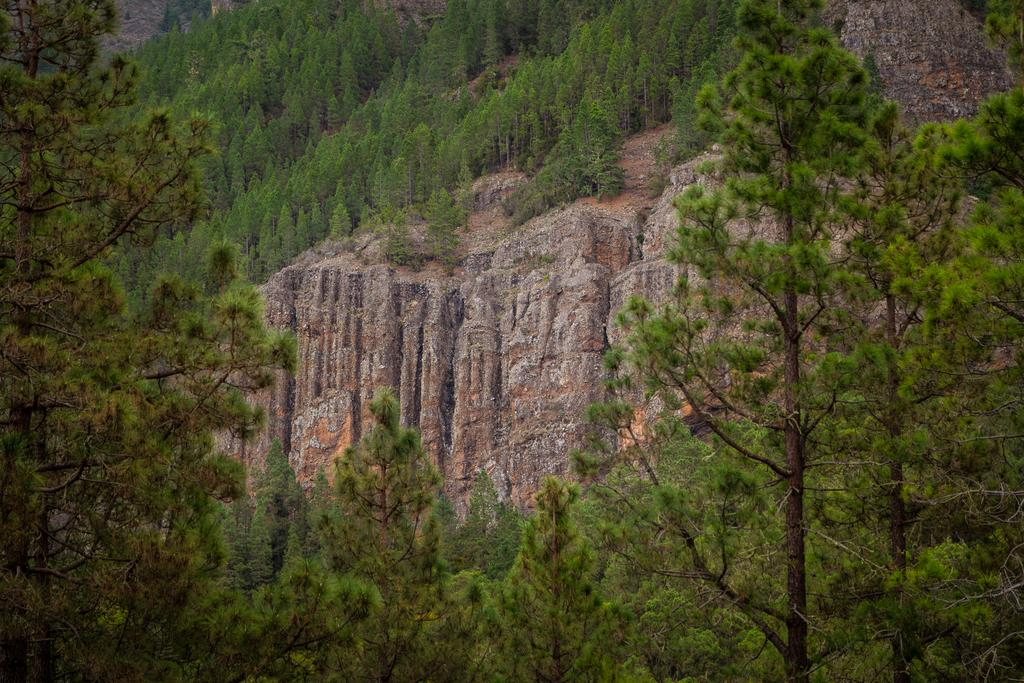Where was the image taken? The image was taken outdoors. What can be seen in the background of the image? There are many trees in the image. Can you describe the plants in the image? The plants have green leaves, stems, and branches. What is the central object in the image? There is a rock in the middle of the image. What type of eggs can be seen in the image? There are no eggs present in the image. What nation is depicted in the image? The image does not depict any specific nation; it features natural elements such as trees, plants, and a rock. 